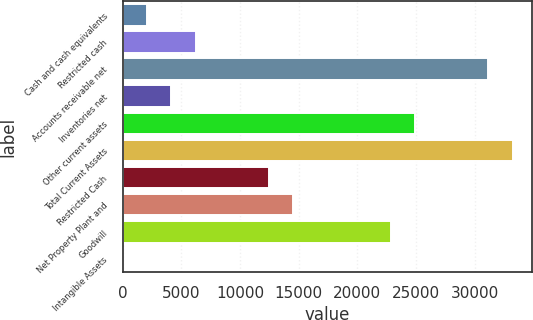Convert chart to OTSL. <chart><loc_0><loc_0><loc_500><loc_500><bar_chart><fcel>Cash and cash equivalents<fcel>Restricted cash<fcel>Accounts receivable net<fcel>Inventories net<fcel>Other current assets<fcel>Total Current Assets<fcel>Restricted Cash<fcel>Net Property Plant and<fcel>Goodwill<fcel>Intangible Assets<nl><fcel>2078.57<fcel>6234.89<fcel>31172.8<fcel>4156.73<fcel>24938.3<fcel>33251<fcel>12469.4<fcel>14547.5<fcel>22860.2<fcel>0.41<nl></chart> 